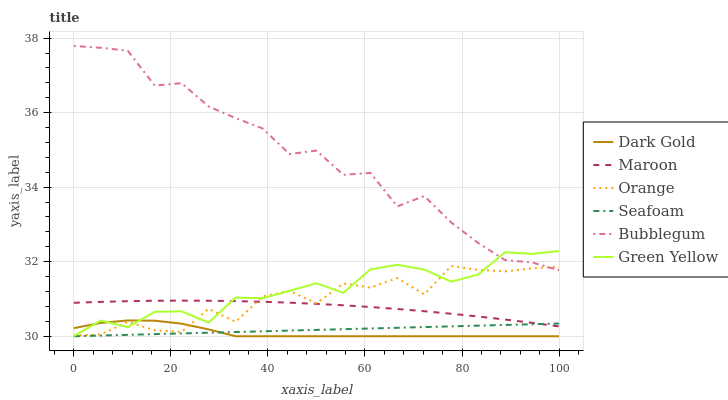Does Dark Gold have the minimum area under the curve?
Answer yes or no. Yes. Does Bubblegum have the maximum area under the curve?
Answer yes or no. Yes. Does Seafoam have the minimum area under the curve?
Answer yes or no. No. Does Seafoam have the maximum area under the curve?
Answer yes or no. No. Is Seafoam the smoothest?
Answer yes or no. Yes. Is Orange the roughest?
Answer yes or no. Yes. Is Bubblegum the smoothest?
Answer yes or no. No. Is Bubblegum the roughest?
Answer yes or no. No. Does Dark Gold have the lowest value?
Answer yes or no. Yes. Does Bubblegum have the lowest value?
Answer yes or no. No. Does Bubblegum have the highest value?
Answer yes or no. Yes. Does Seafoam have the highest value?
Answer yes or no. No. Is Dark Gold less than Maroon?
Answer yes or no. Yes. Is Green Yellow greater than Seafoam?
Answer yes or no. Yes. Does Green Yellow intersect Orange?
Answer yes or no. Yes. Is Green Yellow less than Orange?
Answer yes or no. No. Is Green Yellow greater than Orange?
Answer yes or no. No. Does Dark Gold intersect Maroon?
Answer yes or no. No. 